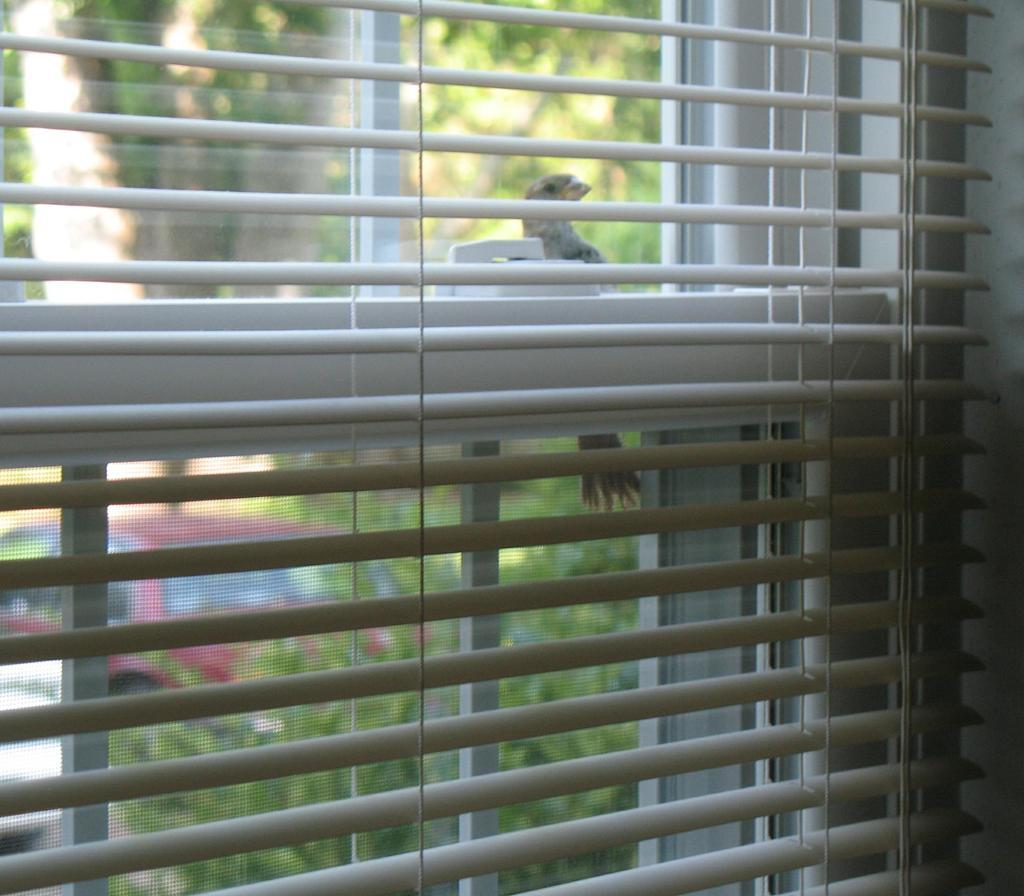What type of window can be seen in the image? There is a glass window with window curtains in the image. What is visible behind the window? There is a bird visible behind the window. What can be seen in the background of the image? There are trees and a car in the background of the image. What type of neck can be seen on the bird in the image? There is no bird's neck visible in the image, as only the bird's body is visible behind the window. What type of land is visible in the image? The image does not show any land; it only shows a bird behind a window, trees, and a car in the background. 